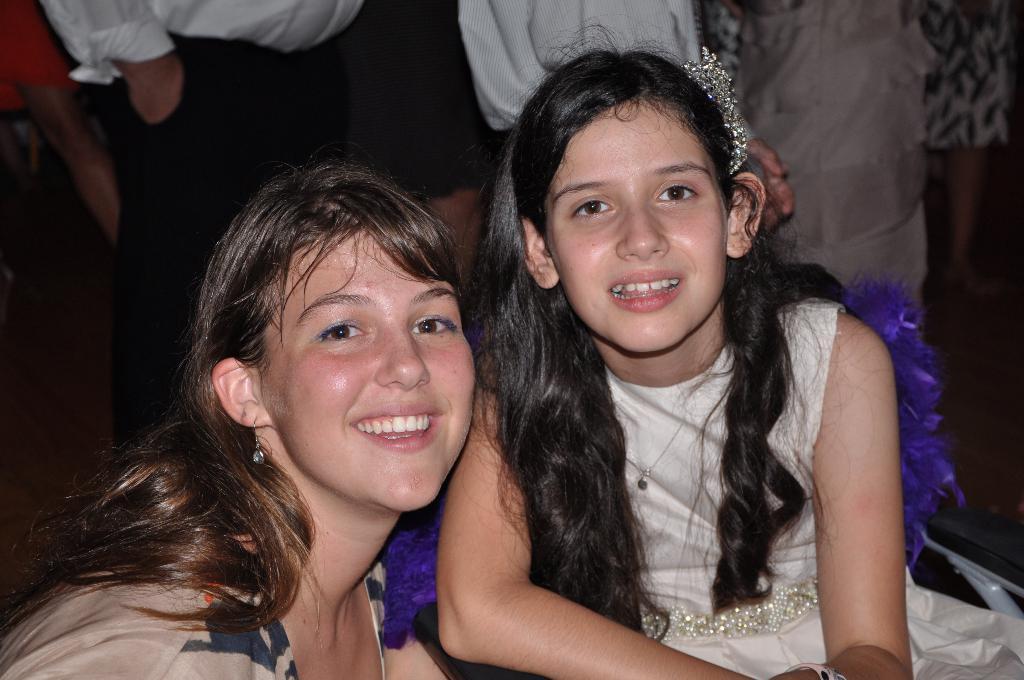Can you describe this image briefly? In this image we can see a lady and a girl smiling. In the background there are people standing. 